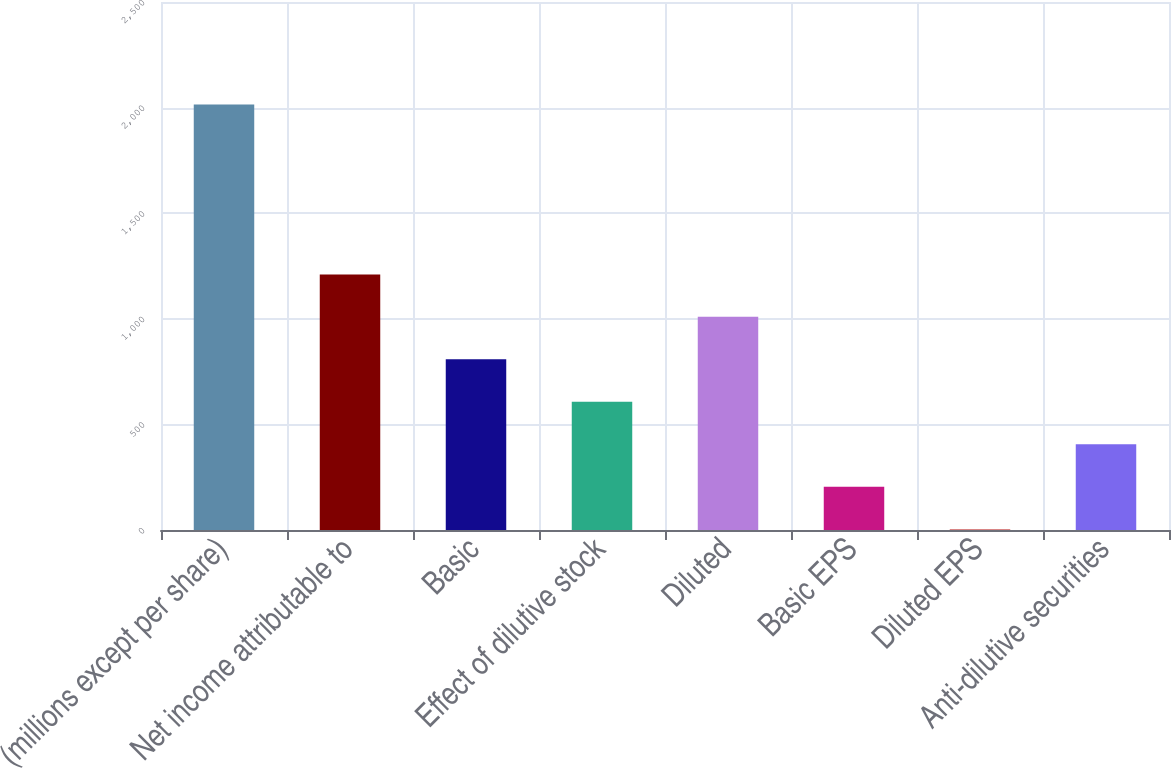<chart> <loc_0><loc_0><loc_500><loc_500><bar_chart><fcel>(millions except per share)<fcel>Net income attributable to<fcel>Basic<fcel>Effect of dilutive stock<fcel>Diluted<fcel>Basic EPS<fcel>Diluted EPS<fcel>Anti-dilutive securities<nl><fcel>2015<fcel>1210.34<fcel>808<fcel>606.83<fcel>1009.17<fcel>204.49<fcel>3.32<fcel>405.66<nl></chart> 